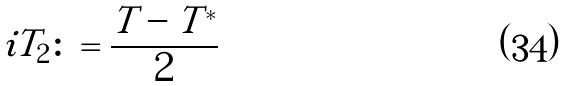<formula> <loc_0><loc_0><loc_500><loc_500>i T _ { 2 } \colon = \frac { T - T ^ { * } } { 2 }</formula> 